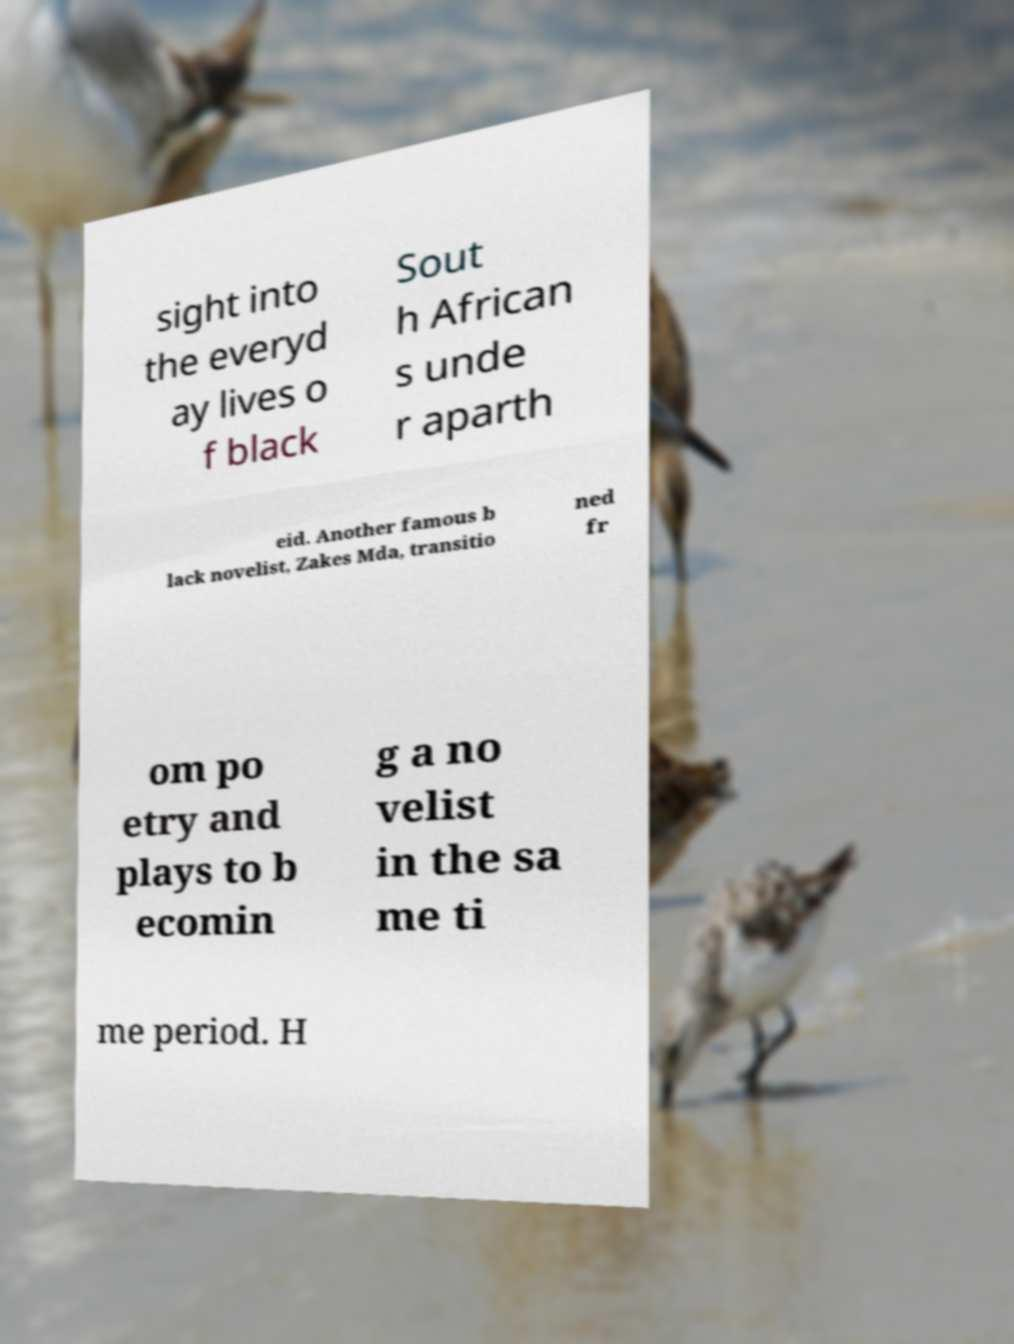What messages or text are displayed in this image? I need them in a readable, typed format. sight into the everyd ay lives o f black Sout h African s unde r aparth eid. Another famous b lack novelist, Zakes Mda, transitio ned fr om po etry and plays to b ecomin g a no velist in the sa me ti me period. H 